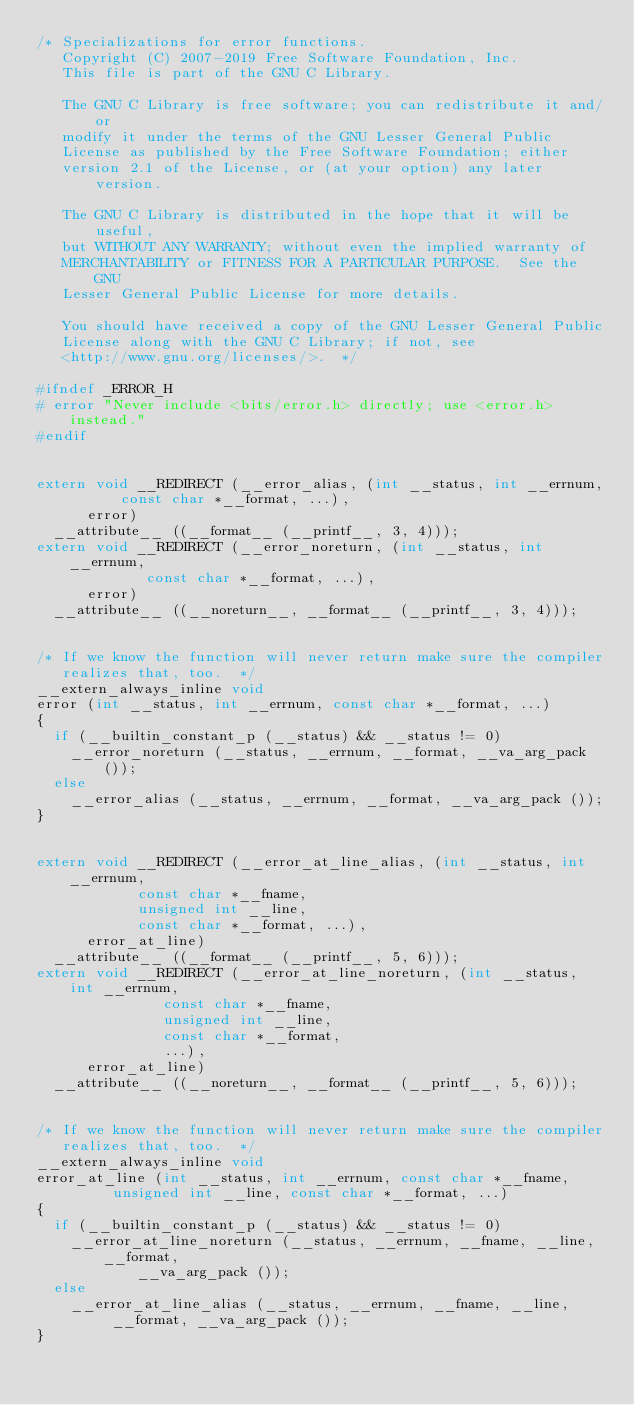Convert code to text. <code><loc_0><loc_0><loc_500><loc_500><_C_>/* Specializations for error functions.
   Copyright (C) 2007-2019 Free Software Foundation, Inc.
   This file is part of the GNU C Library.

   The GNU C Library is free software; you can redistribute it and/or
   modify it under the terms of the GNU Lesser General Public
   License as published by the Free Software Foundation; either
   version 2.1 of the License, or (at your option) any later version.

   The GNU C Library is distributed in the hope that it will be useful,
   but WITHOUT ANY WARRANTY; without even the implied warranty of
   MERCHANTABILITY or FITNESS FOR A PARTICULAR PURPOSE.  See the GNU
   Lesser General Public License for more details.

   You should have received a copy of the GNU Lesser General Public
   License along with the GNU C Library; if not, see
   <http://www.gnu.org/licenses/>.  */

#ifndef	_ERROR_H
# error "Never include <bits/error.h> directly; use <error.h> instead."
#endif


extern void __REDIRECT (__error_alias, (int __status, int __errnum,
					const char *__format, ...),
			error)
  __attribute__ ((__format__ (__printf__, 3, 4)));
extern void __REDIRECT (__error_noreturn, (int __status, int __errnum,
					   const char *__format, ...),
			error)
  __attribute__ ((__noreturn__, __format__ (__printf__, 3, 4)));


/* If we know the function will never return make sure the compiler
   realizes that, too.  */
__extern_always_inline void
error (int __status, int __errnum, const char *__format, ...)
{
  if (__builtin_constant_p (__status) && __status != 0)
    __error_noreturn (__status, __errnum, __format, __va_arg_pack ());
  else
    __error_alias (__status, __errnum, __format, __va_arg_pack ());
}


extern void __REDIRECT (__error_at_line_alias, (int __status, int __errnum,
						const char *__fname,
						unsigned int __line,
						const char *__format, ...),
			error_at_line)
  __attribute__ ((__format__ (__printf__, 5, 6)));
extern void __REDIRECT (__error_at_line_noreturn, (int __status, int __errnum,
						   const char *__fname,
						   unsigned int __line,
						   const char *__format,
						   ...),
			error_at_line)
  __attribute__ ((__noreturn__, __format__ (__printf__, 5, 6)));


/* If we know the function will never return make sure the compiler
   realizes that, too.  */
__extern_always_inline void
error_at_line (int __status, int __errnum, const char *__fname,
	       unsigned int __line, const char *__format, ...)
{
  if (__builtin_constant_p (__status) && __status != 0)
    __error_at_line_noreturn (__status, __errnum, __fname, __line, __format,
			      __va_arg_pack ());
  else
    __error_at_line_alias (__status, __errnum, __fname, __line,
			   __format, __va_arg_pack ());
}
</code> 